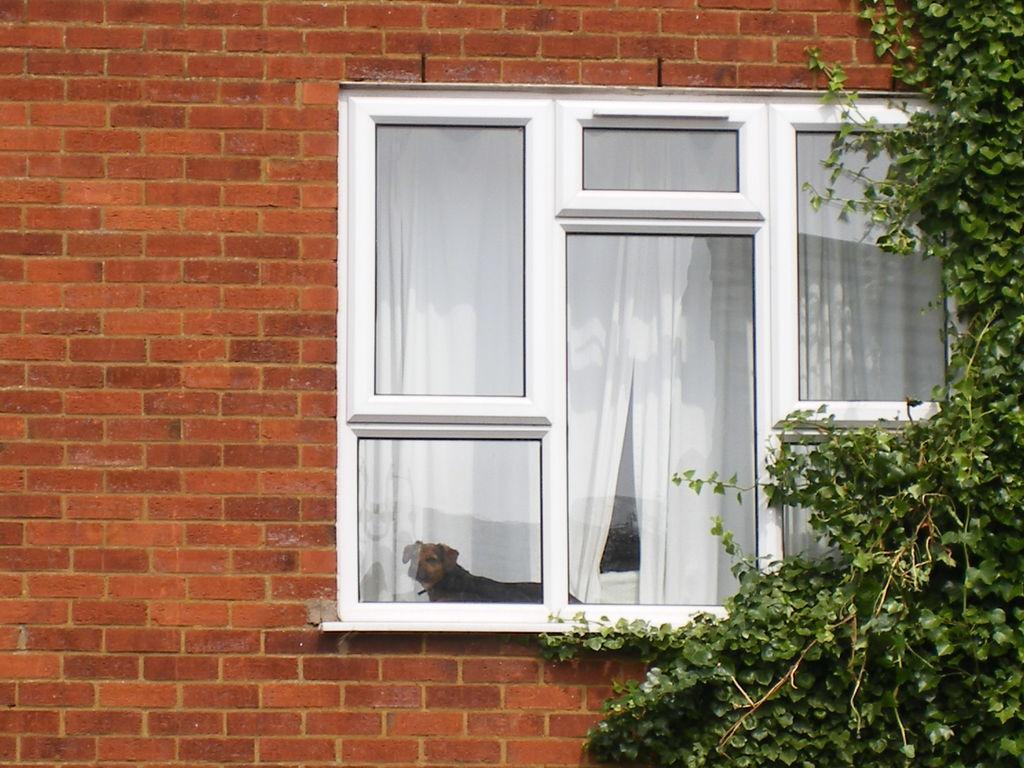Describe this image in one or two sentences. In this image we can see a window, brick wall, plant and behind the window we can see a dog. 